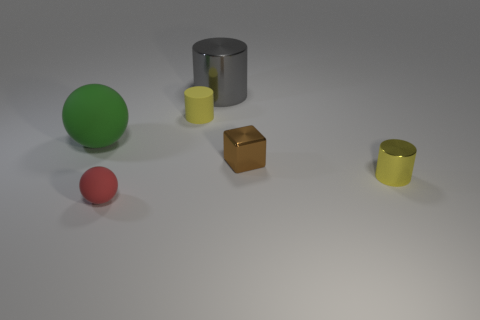Subtract all small yellow shiny cylinders. How many cylinders are left? 2 Subtract 2 spheres. How many spheres are left? 0 Subtract all purple balls. Subtract all gray cubes. How many balls are left? 2 Subtract all blue cylinders. How many green spheres are left? 1 Subtract all red rubber things. Subtract all yellow metallic things. How many objects are left? 4 Add 1 small rubber objects. How many small rubber objects are left? 3 Add 6 small metallic things. How many small metallic things exist? 8 Add 4 big gray things. How many objects exist? 10 Subtract all gray cylinders. How many cylinders are left? 2 Subtract 0 green cylinders. How many objects are left? 6 